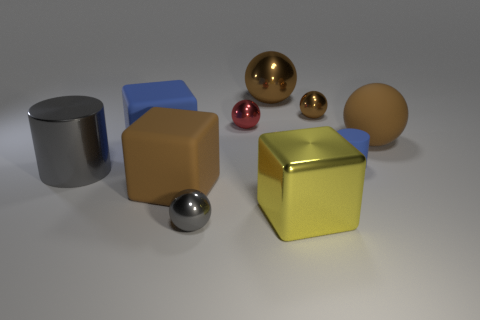Are there more small blue rubber cylinders in front of the yellow shiny block than big red metal things?
Offer a very short reply. No. What material is the gray object that is the same size as the brown matte sphere?
Ensure brevity in your answer.  Metal. Are there any objects of the same size as the blue rubber block?
Offer a very short reply. Yes. There is a sphere that is in front of the matte cylinder; what is its size?
Offer a terse response. Small. How big is the gray metallic sphere?
Provide a short and direct response. Small. What number of balls are either tiny blue rubber things or small brown objects?
Your answer should be very brief. 1. There is a yellow cube that is made of the same material as the large gray cylinder; what is its size?
Offer a terse response. Large. How many small matte things are the same color as the big cylinder?
Make the answer very short. 0. Are there any gray cylinders behind the small red sphere?
Offer a terse response. No. There is a small matte thing; does it have the same shape as the big brown rubber thing on the left side of the large brown metallic object?
Provide a short and direct response. No. 